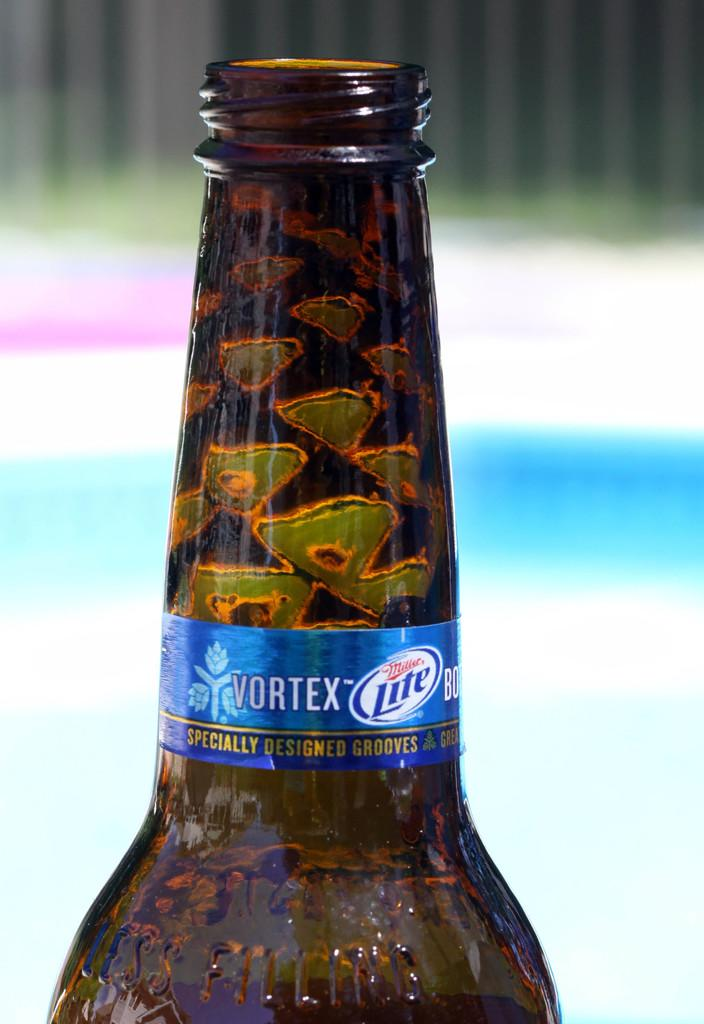<image>
Present a compact description of the photo's key features. a long neck shot of a beer bottle of vortex miller lite 